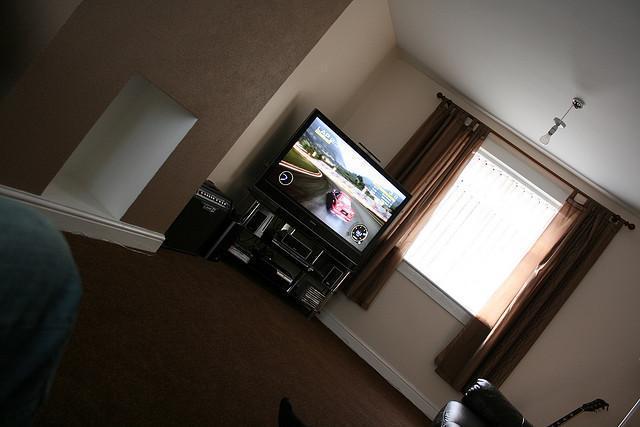How many people are watching the TV?
Give a very brief answer. 1. How many couches are in the picture?
Give a very brief answer. 1. 